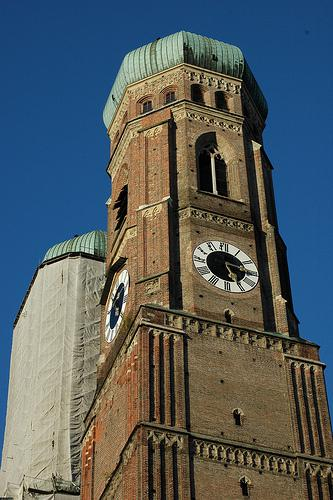Question: how is the day?
Choices:
A. Windy.
B. Rainy.
C. Snowy.
D. Sunny.
Answer with the letter. Answer: D Question: what is the color of the clock?
Choices:
A. Black and white.
B. Brown.
C. Gray.
D. Red.
Answer with the letter. Answer: A Question: what is the color of the sky?
Choices:
A. Red.
B. Blue.
C. Gray.
D. White.
Answer with the letter. Answer: B Question: what is the time shown?
Choices:
A. 12:00.
B. 5:15.
C. 10:00.
D. 2:30.
Answer with the letter. Answer: B 